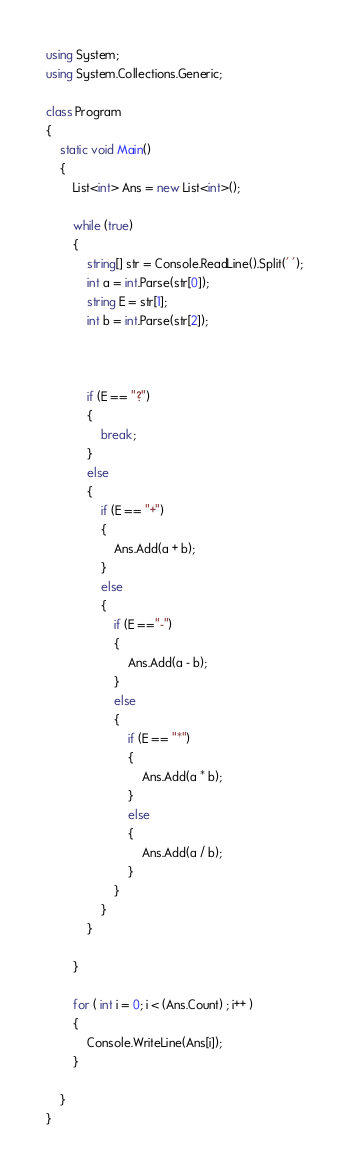Convert code to text. <code><loc_0><loc_0><loc_500><loc_500><_C#_>using System;
using System.Collections.Generic;

class Program
{
    static void Main()
    {
        List<int> Ans = new List<int>();

        while (true)
        {
            string[] str = Console.ReadLine().Split(' ');
            int a = int.Parse(str[0]);
            string E = str[1];
            int b = int.Parse(str[2]);

            

            if (E == "?")
            {
                break;
            }
            else
            {
                if (E == "+")
                {
                    Ans.Add(a + b);
                }
                else
                {
                    if (E =="-")
                    {
                        Ans.Add(a - b);
                    }
                    else
                    {
                        if (E == "*")
                        {
                            Ans.Add(a * b);
                        }
                        else
                        {
                            Ans.Add(a / b);
                        }
                    }
                }
            }
            
        }

        for ( int i = 0; i < (Ans.Count) ; i++ )
        {
            Console.WriteLine(Ans[i]);
        }

    }
}</code> 